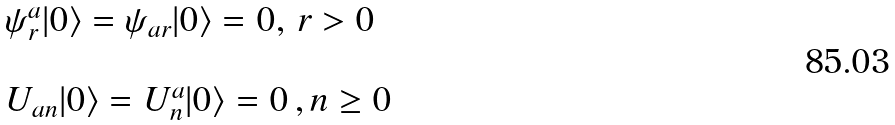<formula> <loc_0><loc_0><loc_500><loc_500>\begin{array} { l } \psi _ { r } ^ { a } | 0 \rangle = \psi _ { a r } | 0 \rangle = 0 , \, r > 0 \\ \ \\ U _ { a n } | 0 \rangle = U ^ { a } _ { n } | 0 \rangle = 0 \, , n \geq 0 \end{array}</formula> 